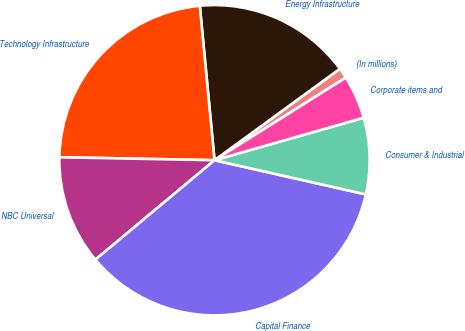Convert chart to OTSL. <chart><loc_0><loc_0><loc_500><loc_500><pie_chart><fcel>(In millions)<fcel>Energy Infrastructure<fcel>Technology Infrastructure<fcel>NBC Universal<fcel>Capital Finance<fcel>Consumer & Industrial<fcel>Corporate items and<nl><fcel>1.09%<fcel>16.48%<fcel>23.18%<fcel>11.38%<fcel>35.39%<fcel>7.95%<fcel>4.52%<nl></chart> 